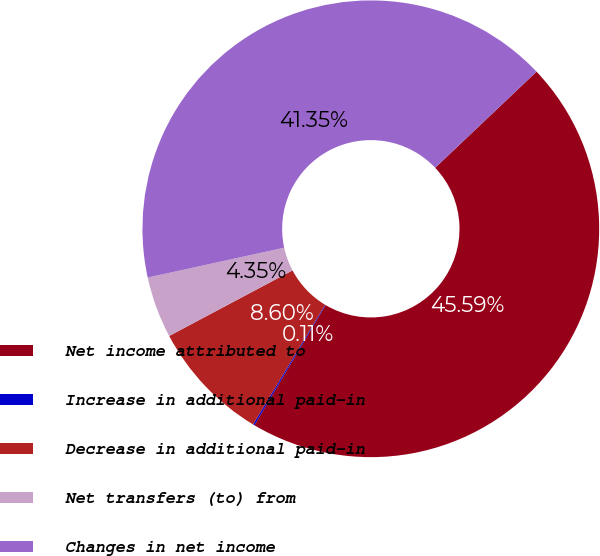Convert chart to OTSL. <chart><loc_0><loc_0><loc_500><loc_500><pie_chart><fcel>Net income attributed to<fcel>Increase in additional paid-in<fcel>Decrease in additional paid-in<fcel>Net transfers (to) from<fcel>Changes in net income<nl><fcel>45.59%<fcel>0.11%<fcel>8.6%<fcel>4.35%<fcel>41.35%<nl></chart> 